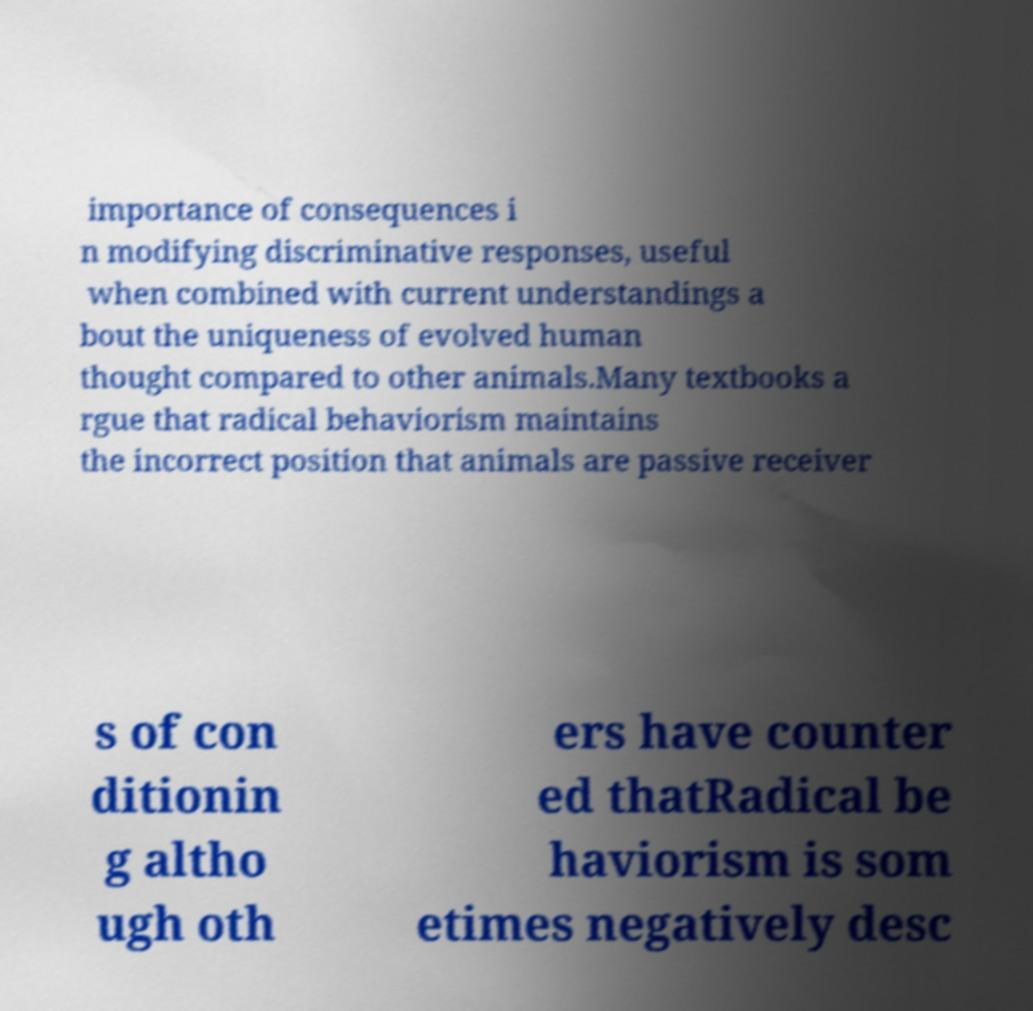I need the written content from this picture converted into text. Can you do that? importance of consequences i n modifying discriminative responses, useful when combined with current understandings a bout the uniqueness of evolved human thought compared to other animals.Many textbooks a rgue that radical behaviorism maintains the incorrect position that animals are passive receiver s of con ditionin g altho ugh oth ers have counter ed thatRadical be haviorism is som etimes negatively desc 